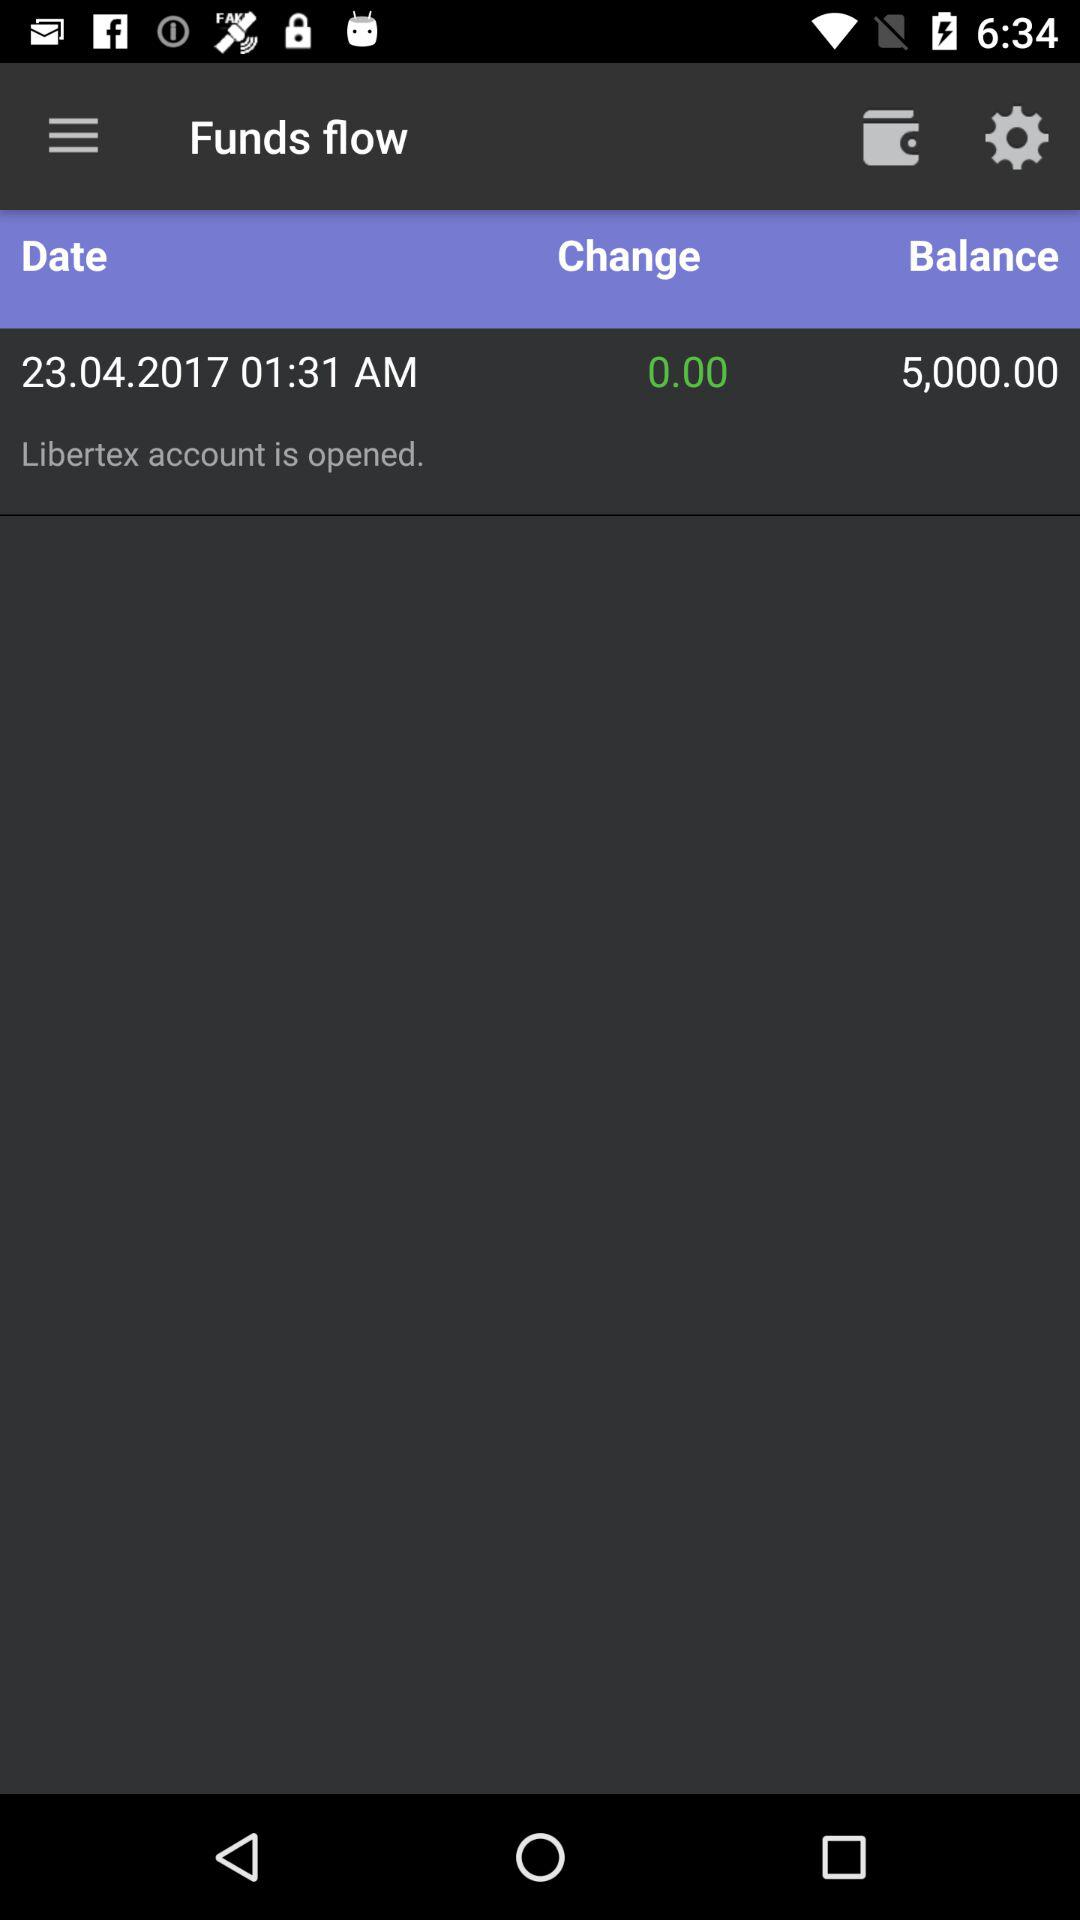What is the status of the "Libertex" account? The status of the "Libertex" account is "opened". 